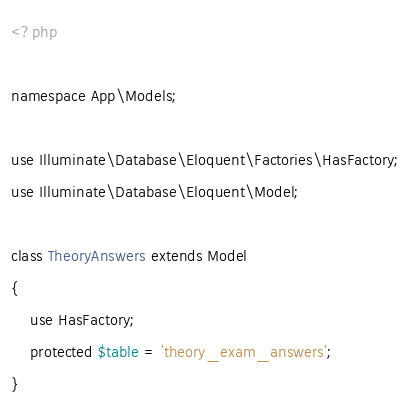Convert code to text. <code><loc_0><loc_0><loc_500><loc_500><_PHP_><?php

namespace App\Models;

use Illuminate\Database\Eloquent\Factories\HasFactory;
use Illuminate\Database\Eloquent\Model;

class TheoryAnswers extends Model
{
    use HasFactory;
    protected $table = 'theory_exam_answers';
}
</code> 